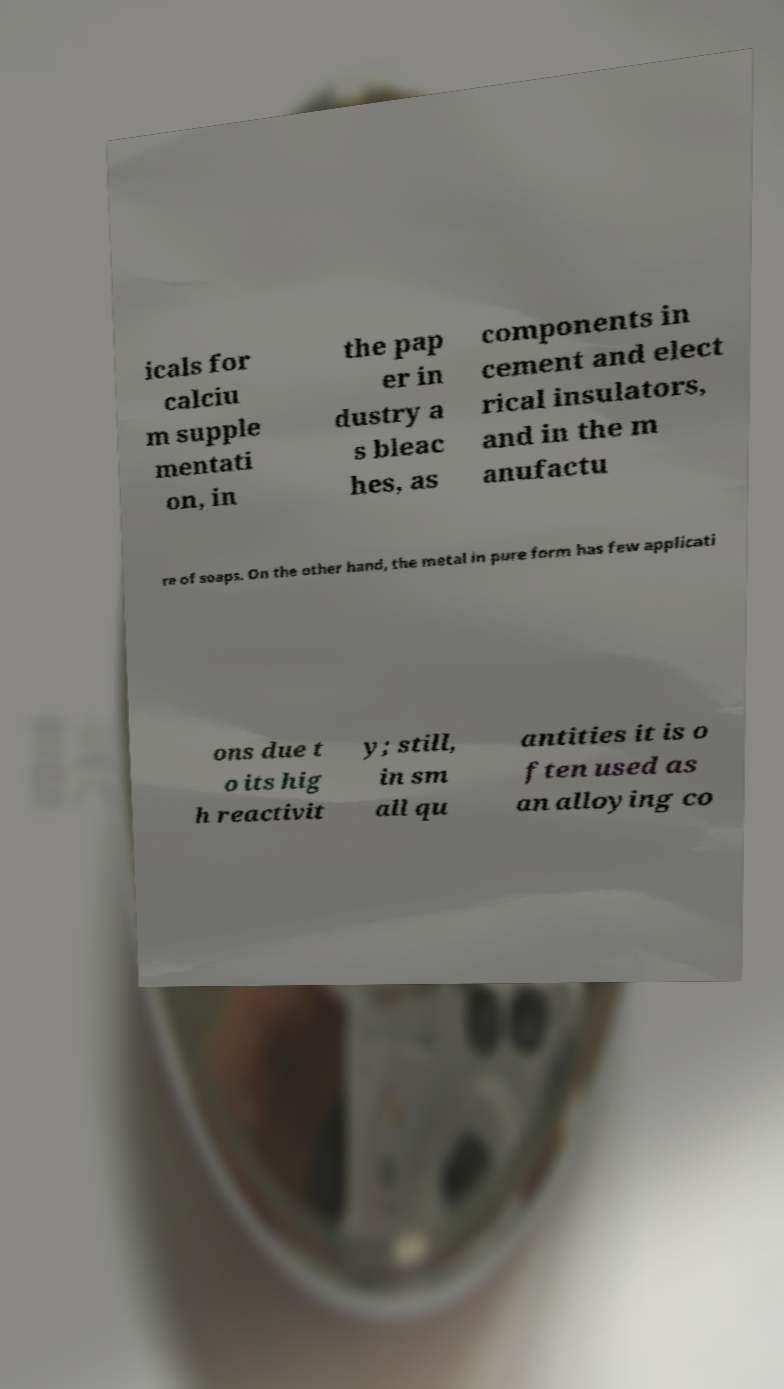Can you accurately transcribe the text from the provided image for me? icals for calciu m supple mentati on, in the pap er in dustry a s bleac hes, as components in cement and elect rical insulators, and in the m anufactu re of soaps. On the other hand, the metal in pure form has few applicati ons due t o its hig h reactivit y; still, in sm all qu antities it is o ften used as an alloying co 